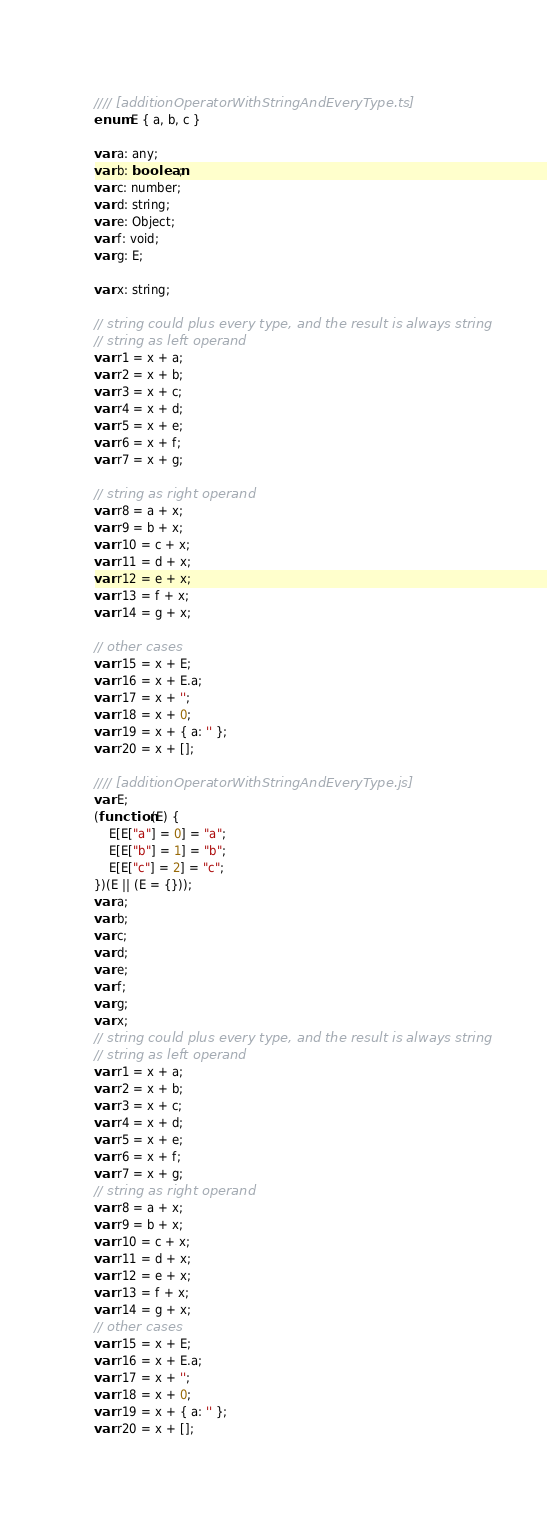Convert code to text. <code><loc_0><loc_0><loc_500><loc_500><_JavaScript_>//// [additionOperatorWithStringAndEveryType.ts]
enum E { a, b, c }

var a: any;
var b: boolean;
var c: number;
var d: string;
var e: Object;
var f: void;
var g: E;

var x: string;

// string could plus every type, and the result is always string
// string as left operand
var r1 = x + a;
var r2 = x + b;
var r3 = x + c;
var r4 = x + d;
var r5 = x + e;
var r6 = x + f;
var r7 = x + g;

// string as right operand
var r8 = a + x;
var r9 = b + x;
var r10 = c + x;
var r11 = d + x;
var r12 = e + x;
var r13 = f + x;
var r14 = g + x;

// other cases
var r15 = x + E;
var r16 = x + E.a;
var r17 = x + '';
var r18 = x + 0;
var r19 = x + { a: '' };
var r20 = x + [];

//// [additionOperatorWithStringAndEveryType.js]
var E;
(function (E) {
    E[E["a"] = 0] = "a";
    E[E["b"] = 1] = "b";
    E[E["c"] = 2] = "c";
})(E || (E = {}));
var a;
var b;
var c;
var d;
var e;
var f;
var g;
var x;
// string could plus every type, and the result is always string
// string as left operand
var r1 = x + a;
var r2 = x + b;
var r3 = x + c;
var r4 = x + d;
var r5 = x + e;
var r6 = x + f;
var r7 = x + g;
// string as right operand
var r8 = a + x;
var r9 = b + x;
var r10 = c + x;
var r11 = d + x;
var r12 = e + x;
var r13 = f + x;
var r14 = g + x;
// other cases
var r15 = x + E;
var r16 = x + E.a;
var r17 = x + '';
var r18 = x + 0;
var r19 = x + { a: '' };
var r20 = x + [];
</code> 